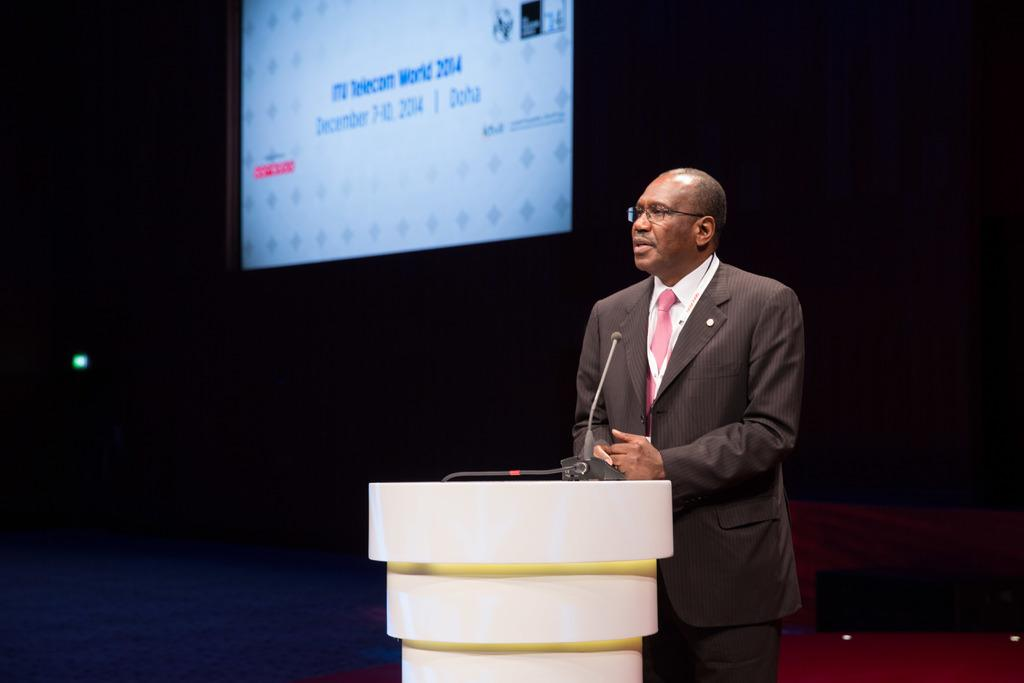What is the main subject of the image? The main subject of the image is a man. What object can be seen near the man in the image? There is a podium in the image. What is on the podium? The podium has a mic on it. What other object is visible in the image? There is a screen in the image. What type of jeans is the man wearing in the image? The image does not provide information about the man's clothing, so it cannot be determined if he is wearing jeans or any other type of clothing. What territory is the man claiming ownership of in the image? The image does not depict any territorial claims or disputes, so it cannot be determined if the man is claiming ownership of any territory. 